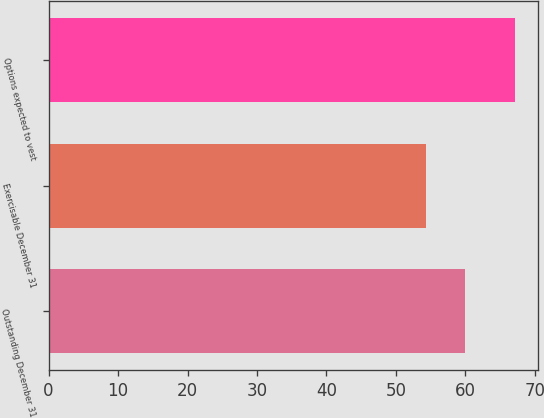Convert chart. <chart><loc_0><loc_0><loc_500><loc_500><bar_chart><fcel>Outstanding December 31<fcel>Exercisable December 31<fcel>Options expected to vest<nl><fcel>59.97<fcel>54.34<fcel>67.17<nl></chart> 